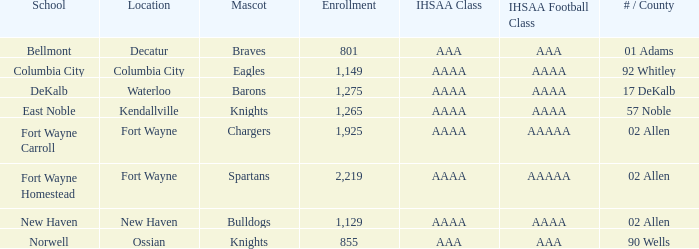What's the IHSAA Football Class in Decatur with an AAA IHSAA class? AAA. 